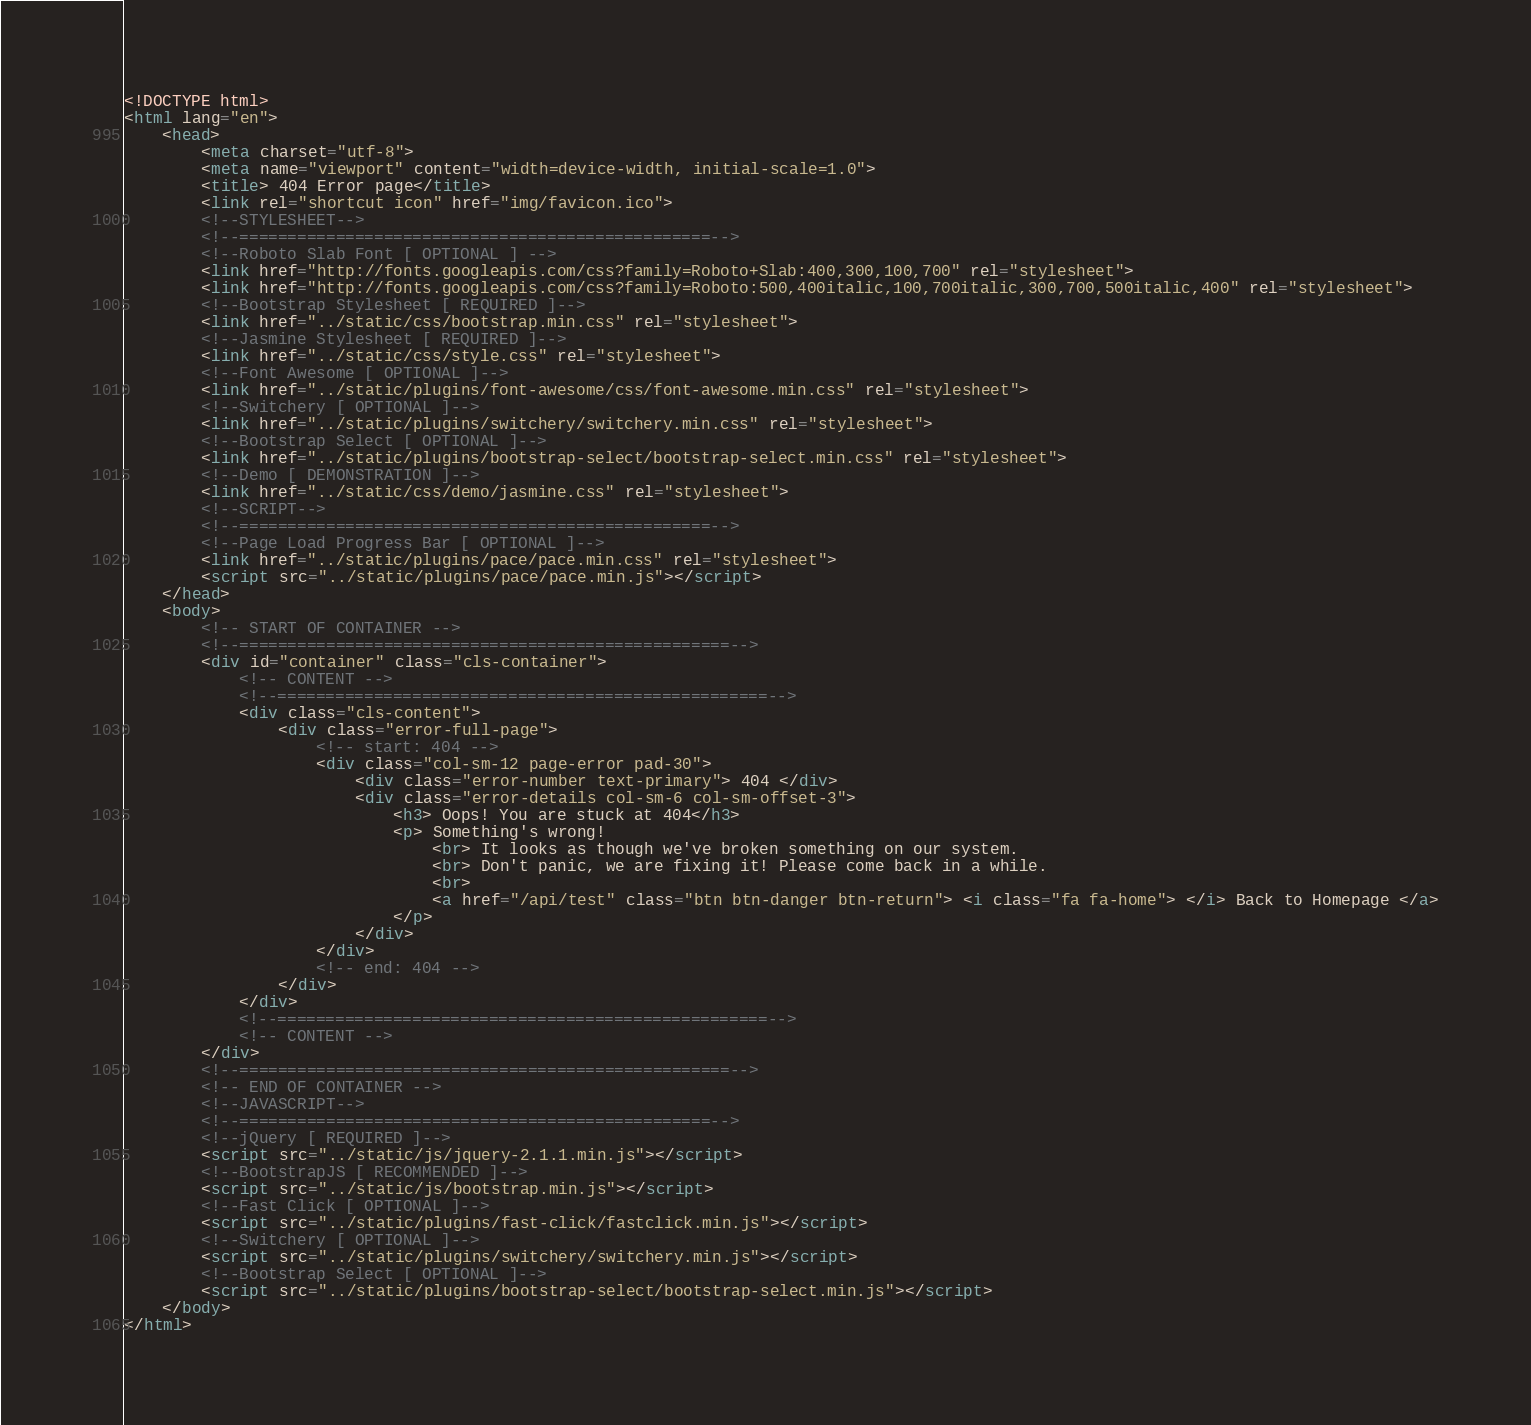<code> <loc_0><loc_0><loc_500><loc_500><_HTML_><!DOCTYPE html>
<html lang="en">
    <head>
        <meta charset="utf-8">
        <meta name="viewport" content="width=device-width, initial-scale=1.0">
        <title> 404 Error page</title>
        <link rel="shortcut icon" href="img/favicon.ico">
        <!--STYLESHEET-->
        <!--=================================================-->
        <!--Roboto Slab Font [ OPTIONAL ] -->
        <link href="http://fonts.googleapis.com/css?family=Roboto+Slab:400,300,100,700" rel="stylesheet">
        <link href="http://fonts.googleapis.com/css?family=Roboto:500,400italic,100,700italic,300,700,500italic,400" rel="stylesheet">
        <!--Bootstrap Stylesheet [ REQUIRED ]-->
        <link href="../static/css/bootstrap.min.css" rel="stylesheet">
        <!--Jasmine Stylesheet [ REQUIRED ]-->
        <link href="../static/css/style.css" rel="stylesheet">
        <!--Font Awesome [ OPTIONAL ]-->
        <link href="../static/plugins/font-awesome/css/font-awesome.min.css" rel="stylesheet">
        <!--Switchery [ OPTIONAL ]-->
        <link href="../static/plugins/switchery/switchery.min.css" rel="stylesheet">
        <!--Bootstrap Select [ OPTIONAL ]-->
        <link href="../static/plugins/bootstrap-select/bootstrap-select.min.css" rel="stylesheet">
        <!--Demo [ DEMONSTRATION ]-->
        <link href="../static/css/demo/jasmine.css" rel="stylesheet">
        <!--SCRIPT-->
        <!--=================================================-->
        <!--Page Load Progress Bar [ OPTIONAL ]-->
        <link href="../static/plugins/pace/pace.min.css" rel="stylesheet">
        <script src="../static/plugins/pace/pace.min.js"></script>
    </head>
    <body>
        <!-- START OF CONTAINER -->
        <!--===================================================-->
        <div id="container" class="cls-container">
            <!-- CONTENT -->
            <!--===================================================-->
            <div class="cls-content">
                <div class="error-full-page">
                    <!-- start: 404 -->
                    <div class="col-sm-12 page-error pad-30">
                        <div class="error-number text-primary"> 404 </div>
                        <div class="error-details col-sm-6 col-sm-offset-3">
                            <h3> Oops! You are stuck at 404</h3>
                            <p> Something's wrong!
                                <br> It looks as though we've broken something on our system.
                                <br> Don't panic, we are fixing it! Please come back in a while.
                                <br>
                                <a href="/api/test" class="btn btn-danger btn-return"> <i class="fa fa-home"> </i> Back to Homepage </a>
                            </p>
                        </div>
                    </div>
                    <!-- end: 404 -->
                </div>
            </div>
            <!--===================================================-->
            <!-- CONTENT -->
        </div>
        <!--===================================================-->
        <!-- END OF CONTAINER -->
        <!--JAVASCRIPT-->
        <!--=================================================-->
        <!--jQuery [ REQUIRED ]-->
        <script src="../static/js/jquery-2.1.1.min.js"></script>
        <!--BootstrapJS [ RECOMMENDED ]-->
        <script src="../static/js/bootstrap.min.js"></script>
        <!--Fast Click [ OPTIONAL ]-->
        <script src="../static/plugins/fast-click/fastclick.min.js"></script>
        <!--Switchery [ OPTIONAL ]-->
        <script src="../static/plugins/switchery/switchery.min.js"></script>
        <!--Bootstrap Select [ OPTIONAL ]-->
        <script src="../static/plugins/bootstrap-select/bootstrap-select.min.js"></script>
    </body>
</html></code> 